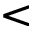Convert formula to latex. <formula><loc_0><loc_0><loc_500><loc_500>\text  less</formula> 